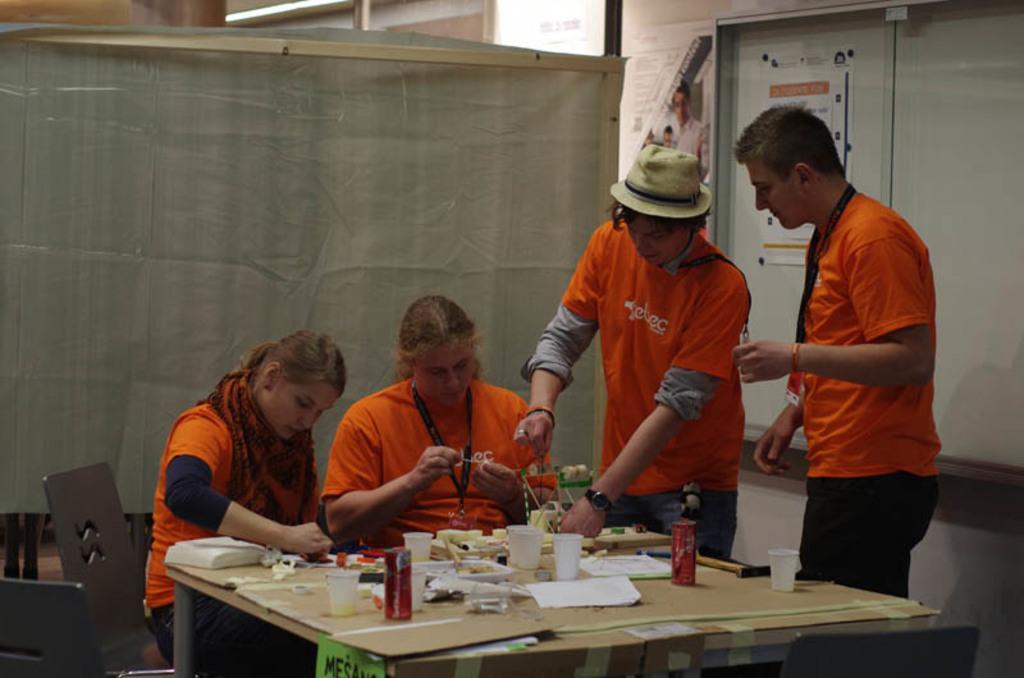Can you describe this image briefly? In this image at the bottom there is one table, on the table there are some bottles, cups, tissue papers and some other objects. And there are some people some of them are standing and some of them are sitting, in the background there is curtain, wall and on the wall there are some posters. 